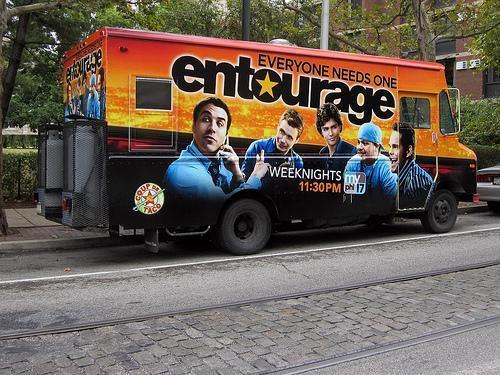How many people are on the advertisement?
Give a very brief answer. 5. 